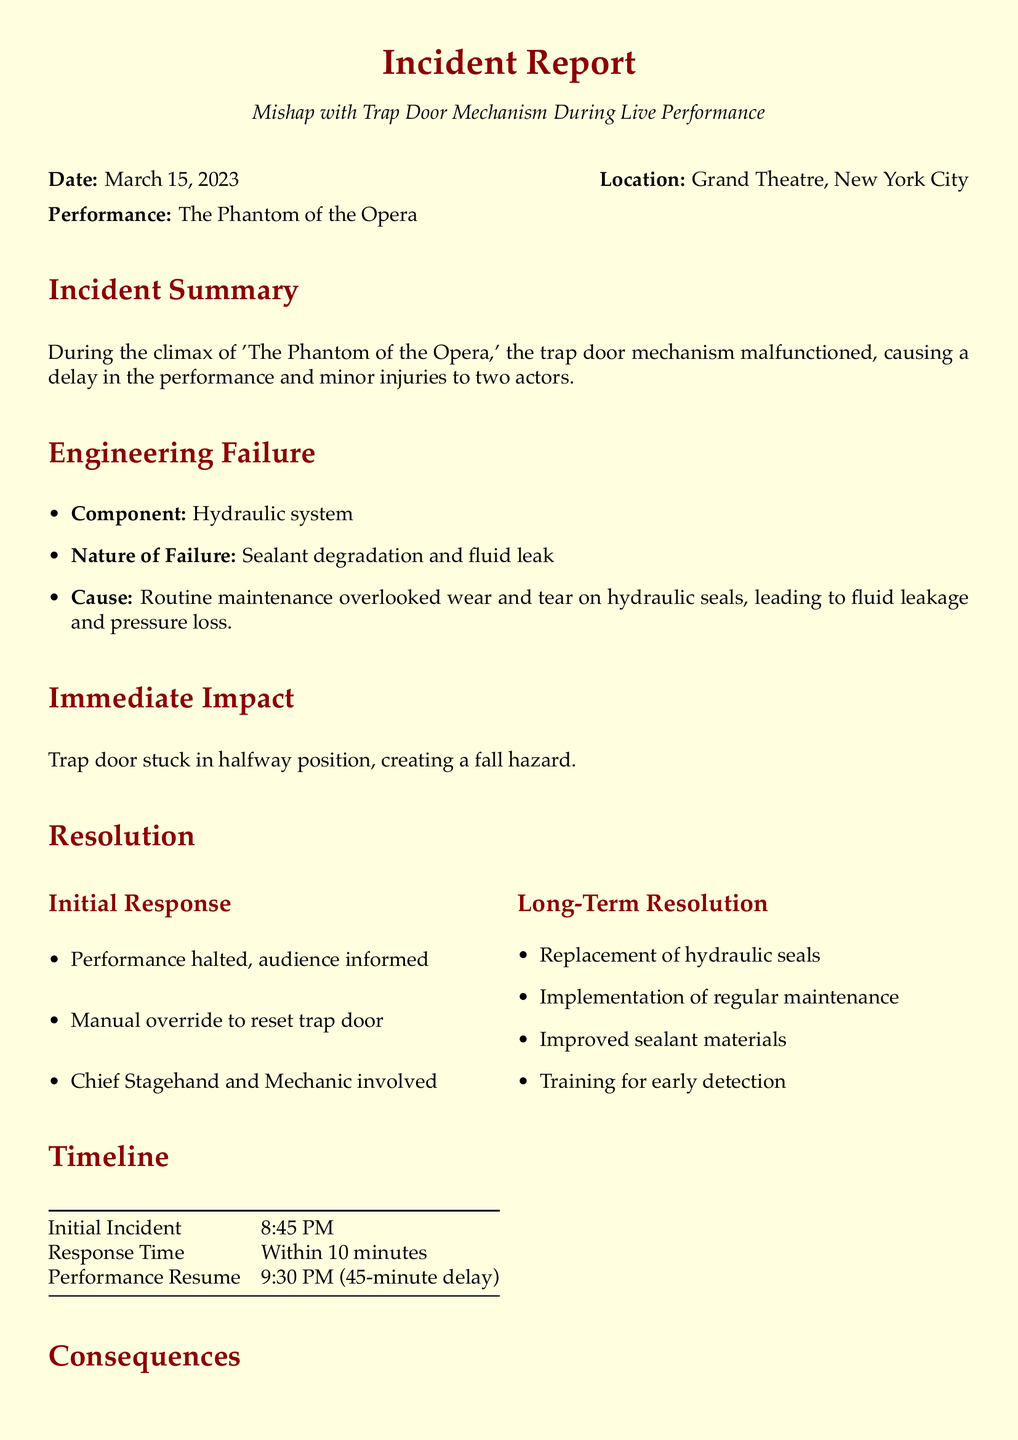What date did the incident occur? The incident occurred on March 15, 2023, as stated in the document.
Answer: March 15, 2023 What was the location of the performance? The location of the performance is mentioned as the Grand Theatre, New York City.
Answer: Grand Theatre, New York City What was the nature of the hydraulic system failure? The document specifies the nature of the failure as sealant degradation and fluid leak.
Answer: Sealant degradation and fluid leak How long was the performance delayed? The document states that the performance resumed 45 minutes later.
Answer: 45 minutes Who sustained a minor ankle sprain? The report names James Carter as the individual who sustained a minor ankle sprain.
Answer: James Carter What was the repair cost associated with the incident? According to the document, the repair costs amounted to $5,000.
Answer: $5,000 What immediate action was taken after the incident? The document mentions that the performance was halted, and the audience was informed.
Answer: Performance halted What improvement was made for long-term resolution regarding maintenance? The document states that regular maintenance was implemented for long-term resolution.
Answer: Regular maintenance What training was suggested for future incidents? The conclusion indicates that training for early detection was part of the long-term resolution.
Answer: Training for early detection 